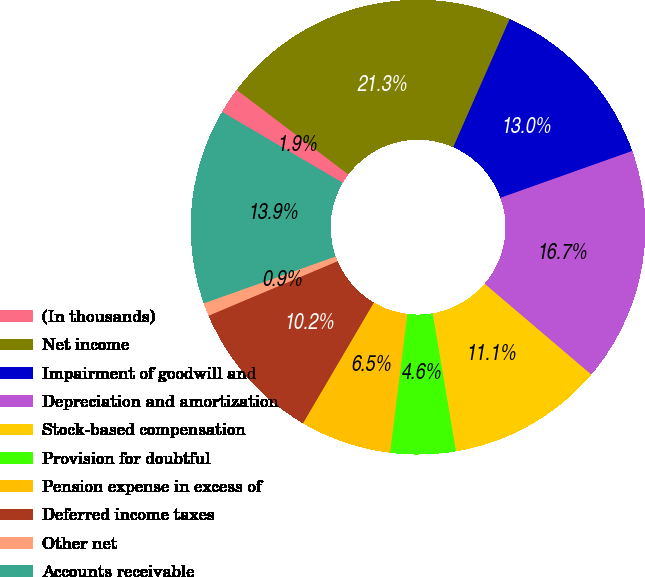<chart> <loc_0><loc_0><loc_500><loc_500><pie_chart><fcel>(In thousands)<fcel>Net income<fcel>Impairment of goodwill and<fcel>Depreciation and amortization<fcel>Stock-based compensation<fcel>Provision for doubtful<fcel>Pension expense in excess of<fcel>Deferred income taxes<fcel>Other net<fcel>Accounts receivable<nl><fcel>1.86%<fcel>21.29%<fcel>12.96%<fcel>16.66%<fcel>11.11%<fcel>4.63%<fcel>6.48%<fcel>10.19%<fcel>0.93%<fcel>13.89%<nl></chart> 